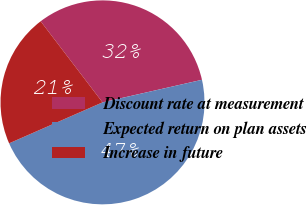<chart> <loc_0><loc_0><loc_500><loc_500><pie_chart><fcel>Discount rate at measurement<fcel>Expected return on plan assets<fcel>Increase in future<nl><fcel>31.82%<fcel>46.97%<fcel>21.21%<nl></chart> 